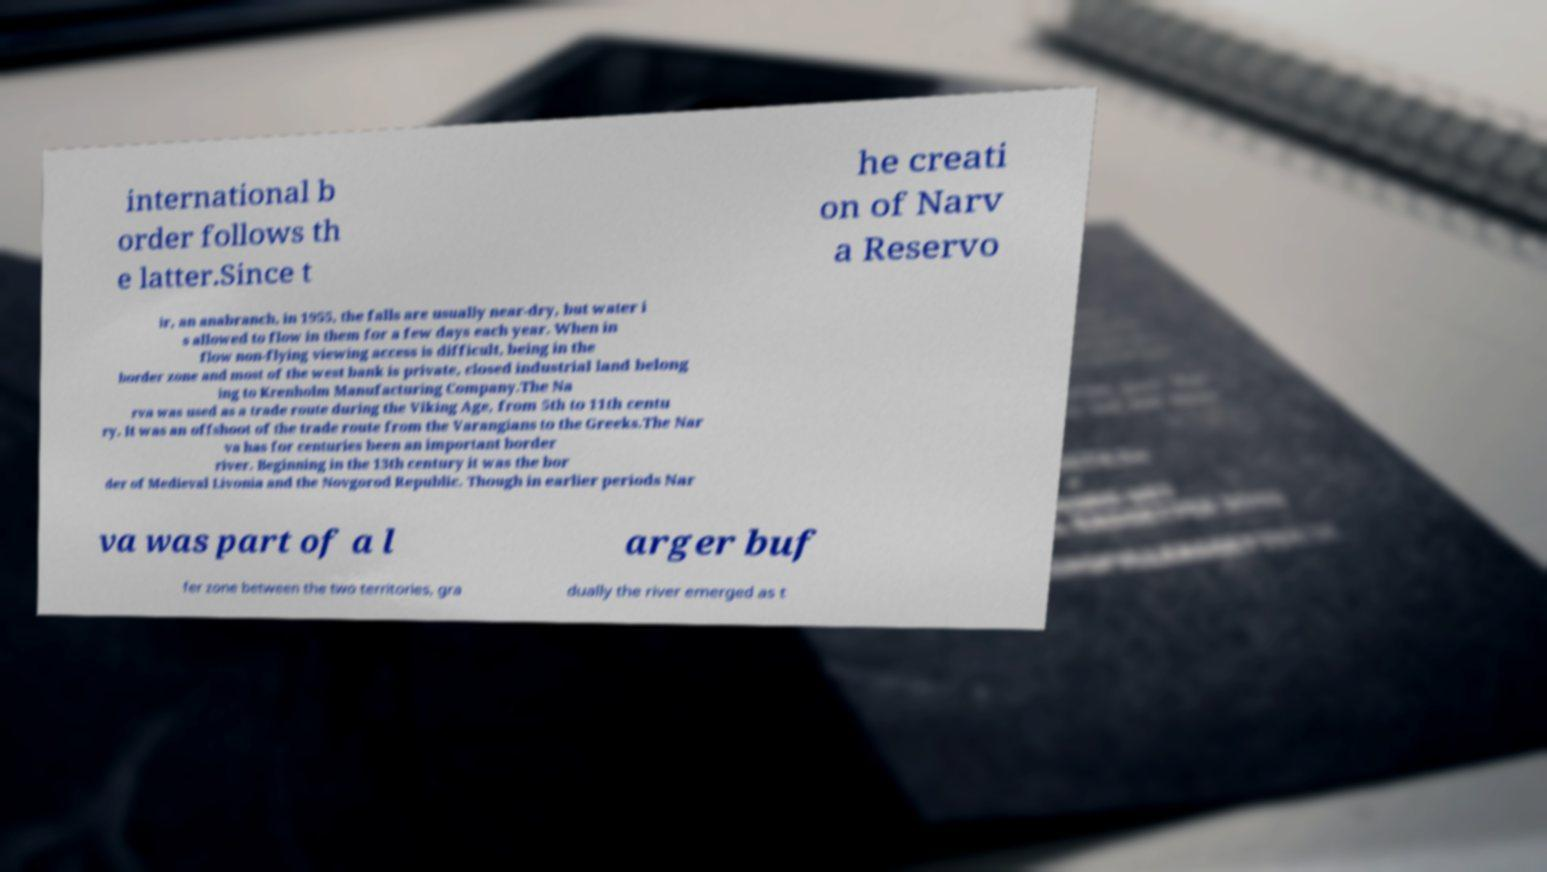Please identify and transcribe the text found in this image. international b order follows th e latter.Since t he creati on of Narv a Reservo ir, an anabranch, in 1955, the falls are usually near-dry, but water i s allowed to flow in them for a few days each year. When in flow non-flying viewing access is difficult, being in the border zone and most of the west bank is private, closed industrial land belong ing to Krenholm Manufacturing Company.The Na rva was used as a trade route during the Viking Age, from 5th to 11th centu ry. It was an offshoot of the trade route from the Varangians to the Greeks.The Nar va has for centuries been an important border river. Beginning in the 13th century it was the bor der of Medieval Livonia and the Novgorod Republic. Though in earlier periods Nar va was part of a l arger buf fer zone between the two territories, gra dually the river emerged as t 